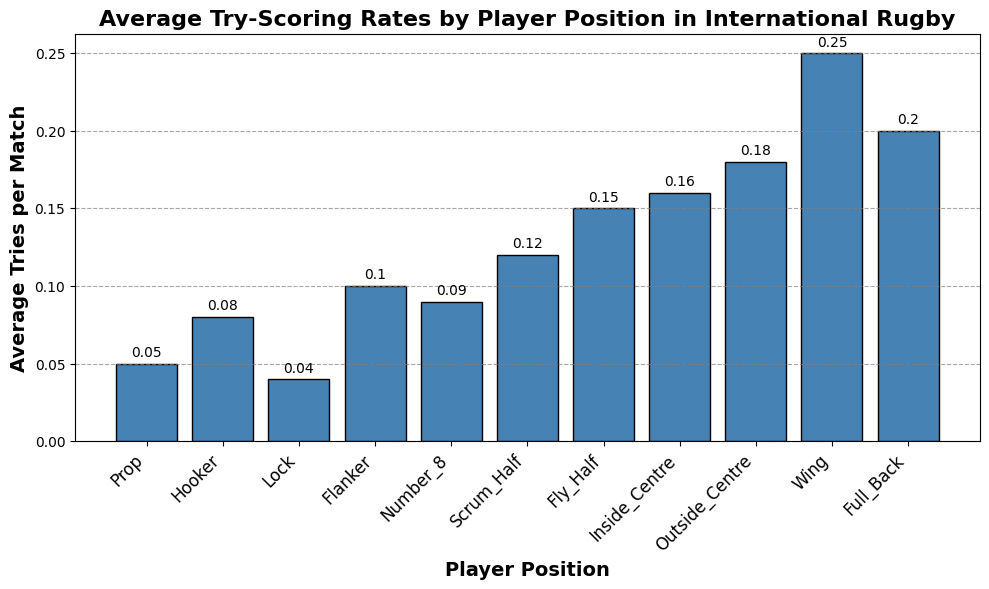Which player position has the highest average tries per match? The Wing position's bar is the tallest in the histogram, indicating it has the highest average tries per match.
Answer: Wing What is the difference in average tries per match between a Fly Half and a Lock? From the histogram, the average tries per match for a Fly Half is 0.15 and for a Lock is 0.04. The difference is calculated as 0.15 - 0.04.
Answer: 0.11 Which position scores more average tries per match, an Outside Centre or a Full Back? Comparing the bars, the Outside Centre's bar is taller than the Full Back's bar, indicating it scores more average tries per match.
Answer: Outside Centre How many positions have an average tries per match greater than 0.1? From the histogram, the positions with average tries per match greater than 0.1 are Scrum Half, Fly Half, Inside Centre, Outside Centre, Wing, and Full Back. Count these positions.
Answer: 6 What are the average tries per match for the Prop and Number 8 positions? The histogram shows the average tries per match for the Prop is 0.05 and for the Number 8 is 0.09.
Answer: Prop: 0.05, Number 8: 0.09 Is the average tries per match for a Hooker greater than for a Lock? Compare the bars for the Hooker and Lock positions; the Hooker bar is taller, indicating its average tries per match is greater.
Answer: Yes What is the sum of the average tries per match for the Wing, Full Back, and Inside Centre positions? The histogram shows the average tries per match are 0.25 for Wing, 0.2 for Full Back, and 0.16 for Inside Centre. Add these values: 0.25 + 0.2 + 0.16.
Answer: 0.61 Which position has a lower average tries per match, a Flanker or a Number 8? Compare the bars for Flanker and Number 8; the Number 8's bar is slightly lower than the Flanker's bar.
Answer: Number 8 What is the range of average tries per match among all positions? The Wing has the highest average tries per match at 0.25, and the Lock has the lowest at 0.04. The range is the difference between these: 0.25 - 0.04.
Answer: 0.21 